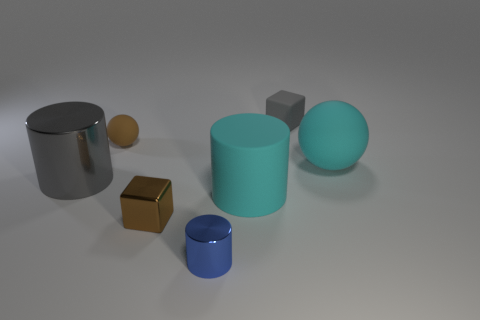Is the size of the brown metallic thing that is in front of the gray matte thing the same as the cyan cylinder?
Provide a succinct answer. No. What is the shape of the big thing that is both right of the small blue metallic thing and on the left side of the small gray rubber cube?
Your answer should be compact. Cylinder. There is a tiny matte ball; does it have the same color as the cylinder to the left of the tiny brown rubber object?
Your answer should be very brief. No. The metal cylinder right of the sphere that is behind the rubber sphere that is to the right of the brown metallic block is what color?
Offer a terse response. Blue. The rubber thing that is the same shape as the big metallic object is what color?
Keep it short and to the point. Cyan. Is the number of gray objects behind the blue metallic cylinder the same as the number of tiny green rubber spheres?
Offer a terse response. No. How many blocks are either brown matte objects or gray metal things?
Provide a succinct answer. 0. What color is the big cylinder that is made of the same material as the blue thing?
Your response must be concise. Gray. Does the cyan sphere have the same material as the cylinder that is in front of the big cyan cylinder?
Provide a succinct answer. No. What number of things are metal cylinders or cyan rubber balls?
Offer a terse response. 3. 